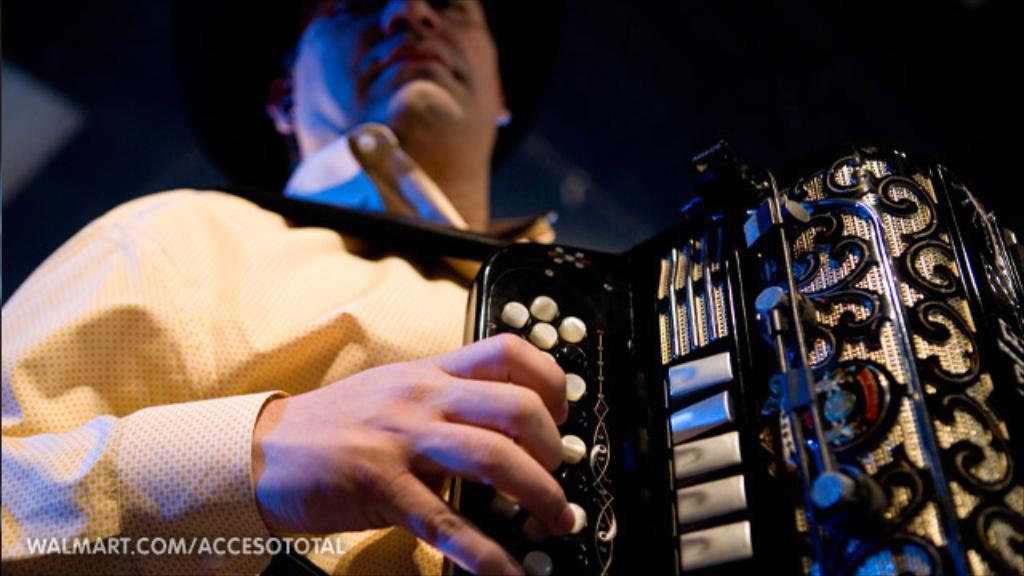What is the main subject of the image? There is a man in the image. What is the man doing in the image? The man is standing and playing a musical instrument. Is there any text present in the image? Yes, there is text on the image. How would you describe the background of the image? The background of the image is blurred. How much dirt is visible on the man's shoes in the image? There is no information about the man's shoes or the presence of dirt in the image. Are there any sheep visible in the background of the image? There are no sheep present in the image; the background is blurred. 